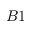<formula> <loc_0><loc_0><loc_500><loc_500>B 1</formula> 